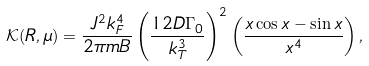Convert formula to latex. <formula><loc_0><loc_0><loc_500><loc_500>\mathcal { K } ( R , \mu ) = \frac { J ^ { 2 } k _ { F } ^ { 4 } } { 2 \pi { m B } } \left ( \frac { 1 2 D \Gamma _ { 0 } } { k _ { T } ^ { 3 } } \right ) ^ { 2 } \left ( \frac { x \cos { x } - \sin { x } } { x ^ { 4 } } \right ) ,</formula> 